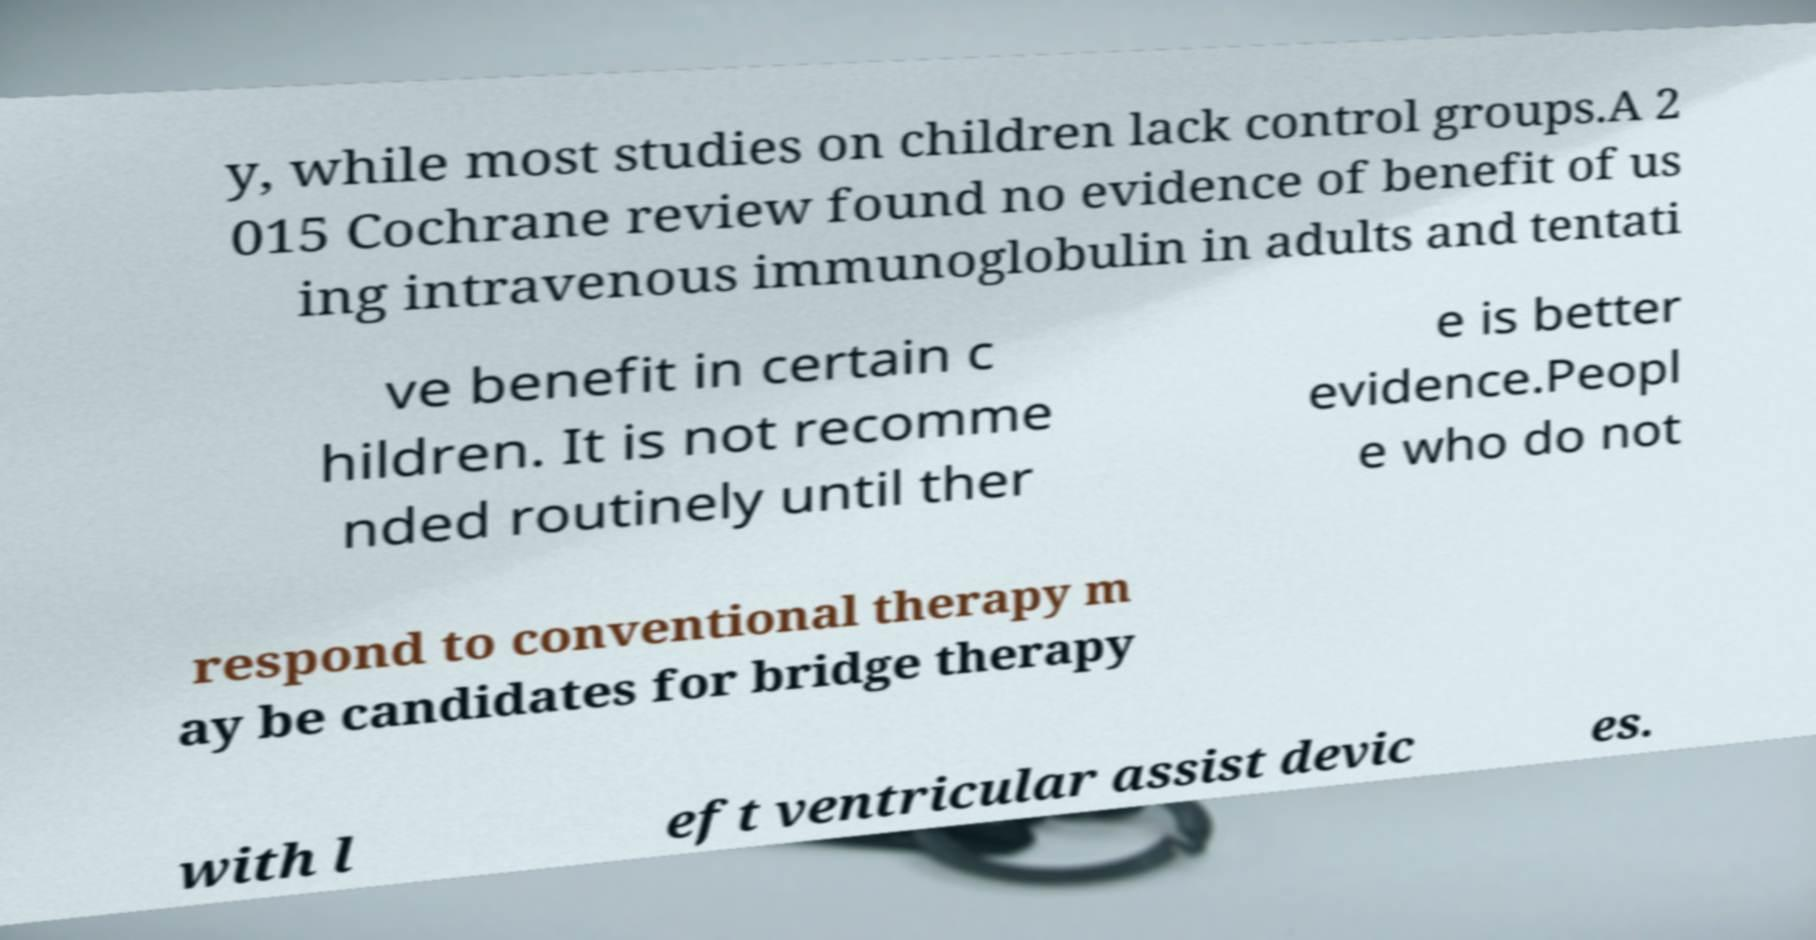I need the written content from this picture converted into text. Can you do that? y, while most studies on children lack control groups.A 2 015 Cochrane review found no evidence of benefit of us ing intravenous immunoglobulin in adults and tentati ve benefit in certain c hildren. It is not recomme nded routinely until ther e is better evidence.Peopl e who do not respond to conventional therapy m ay be candidates for bridge therapy with l eft ventricular assist devic es. 